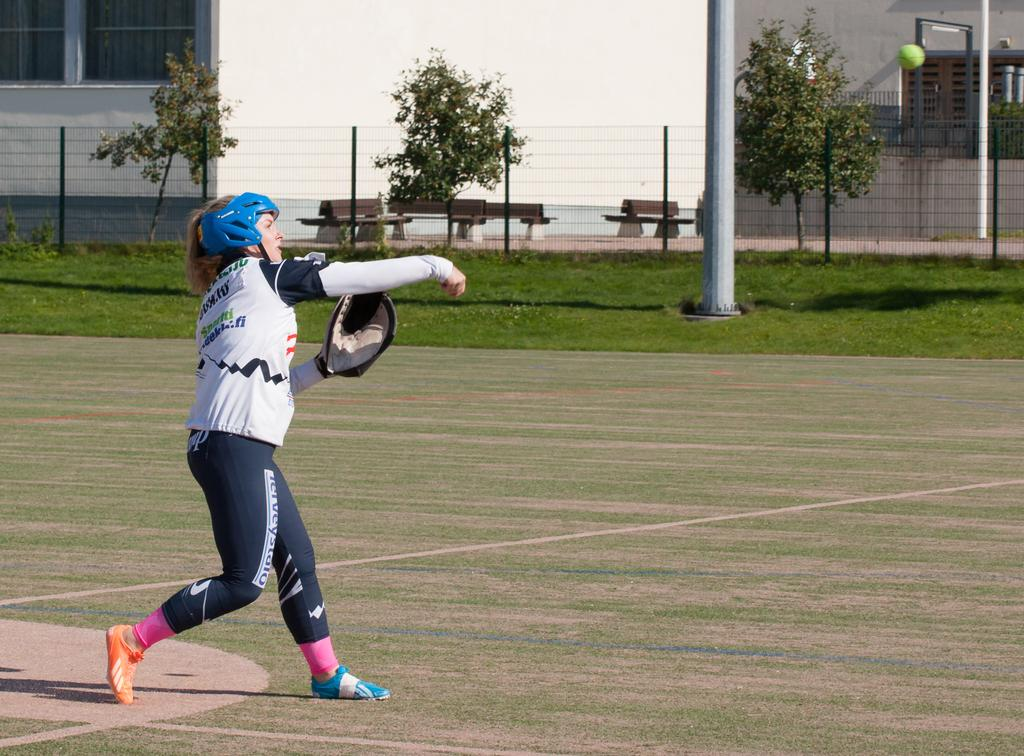What is the main subject of the image? There is a person standing in the image. What objects are present in the image besides the person? There are poles, benches, trees, net fencing, a ball, buildings, and windows in the image. How many arms does the ghost have in the image? There is no ghost present in the image. What type of cattle can be seen grazing in the image? There is no cattle present in the image. 